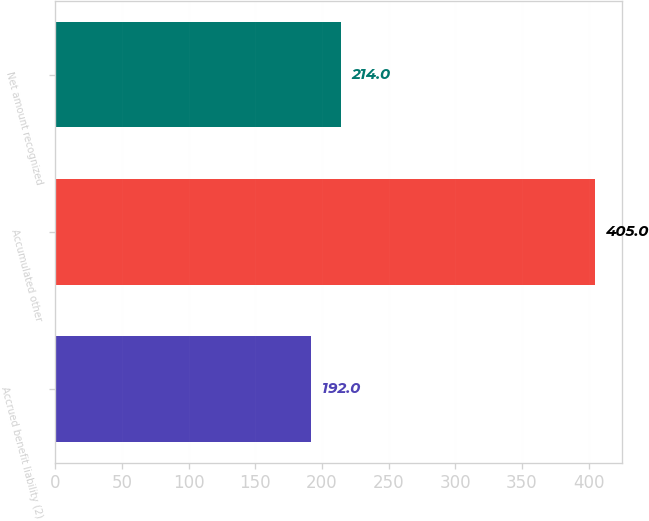Convert chart to OTSL. <chart><loc_0><loc_0><loc_500><loc_500><bar_chart><fcel>Accrued benefit liability (2)<fcel>Accumulated other<fcel>Net amount recognized<nl><fcel>192<fcel>405<fcel>214<nl></chart> 